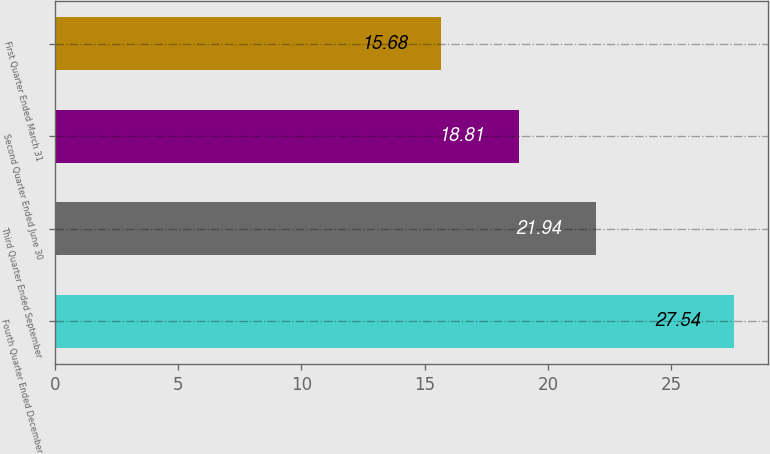<chart> <loc_0><loc_0><loc_500><loc_500><bar_chart><fcel>Fourth Quarter Ended December<fcel>Third Quarter Ended September<fcel>Second Quarter Ended June 30<fcel>First Quarter Ended March 31<nl><fcel>27.54<fcel>21.94<fcel>18.81<fcel>15.68<nl></chart> 